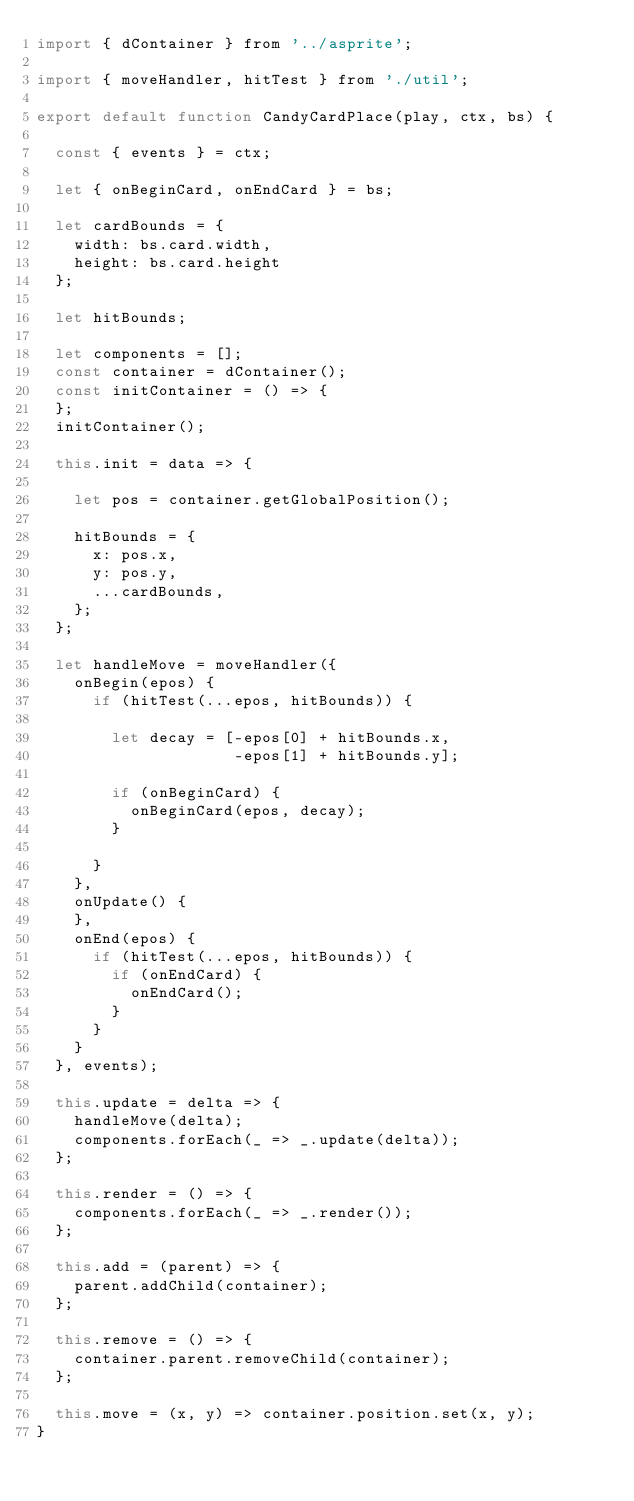<code> <loc_0><loc_0><loc_500><loc_500><_JavaScript_>import { dContainer } from '../asprite';

import { moveHandler, hitTest } from './util';

export default function CandyCardPlace(play, ctx, bs) {

  const { events } = ctx;

  let { onBeginCard, onEndCard } = bs;

  let cardBounds = {
    width: bs.card.width,
    height: bs.card.height
  };

  let hitBounds;

  let components = [];
  const container = dContainer();
  const initContainer = () => {
  };
  initContainer();

  this.init = data => {

    let pos = container.getGlobalPosition();

    hitBounds = {
      x: pos.x,
      y: pos.y,
      ...cardBounds,
    };
  };

  let handleMove = moveHandler({
    onBegin(epos) {
      if (hitTest(...epos, hitBounds)) {
        
        let decay = [-epos[0] + hitBounds.x,
                     -epos[1] + hitBounds.y];

        if (onBeginCard) {
          onBeginCard(epos, decay);
        }

      }
    },
    onUpdate() {
    },
    onEnd(epos) {
      if (hitTest(...epos, hitBounds)) {
        if (onEndCard) {
          onEndCard();
        }
      }
    }
  }, events);

  this.update = delta => {
    handleMove(delta);
    components.forEach(_ => _.update(delta));
  };

  this.render = () => {
    components.forEach(_ => _.render());
  };

  this.add = (parent) => {
    parent.addChild(container);
  };

  this.remove = () => {
    container.parent.removeChild(container);
  };

  this.move = (x, y) => container.position.set(x, y);
}
</code> 